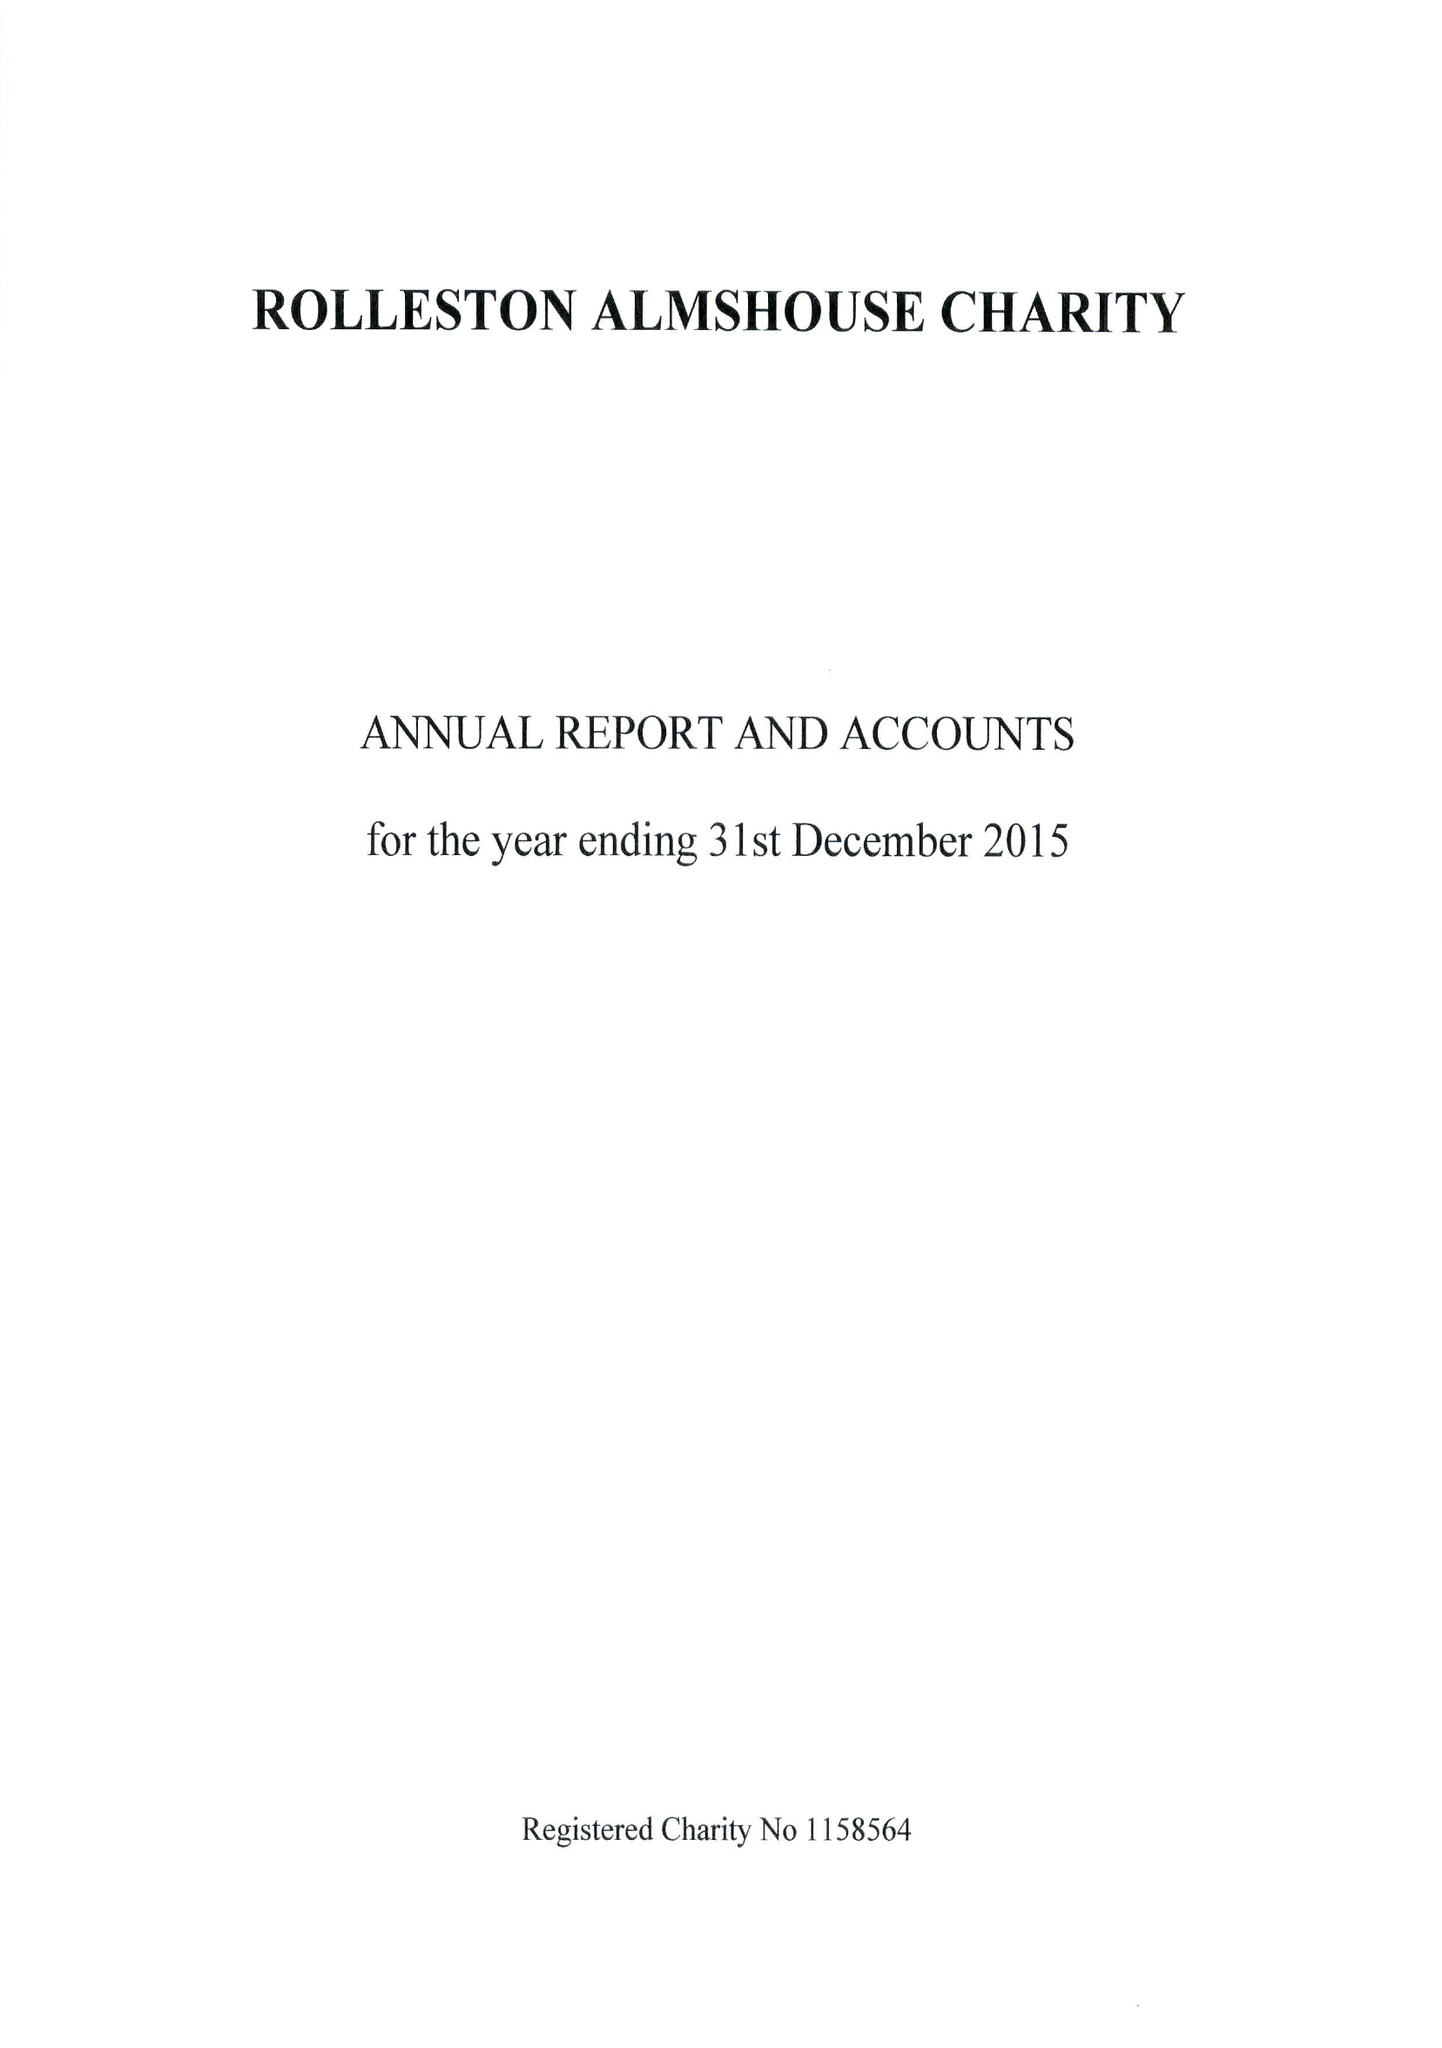What is the value for the address__street_line?
Answer the question using a single word or phrase. 148 HIGH STREET 